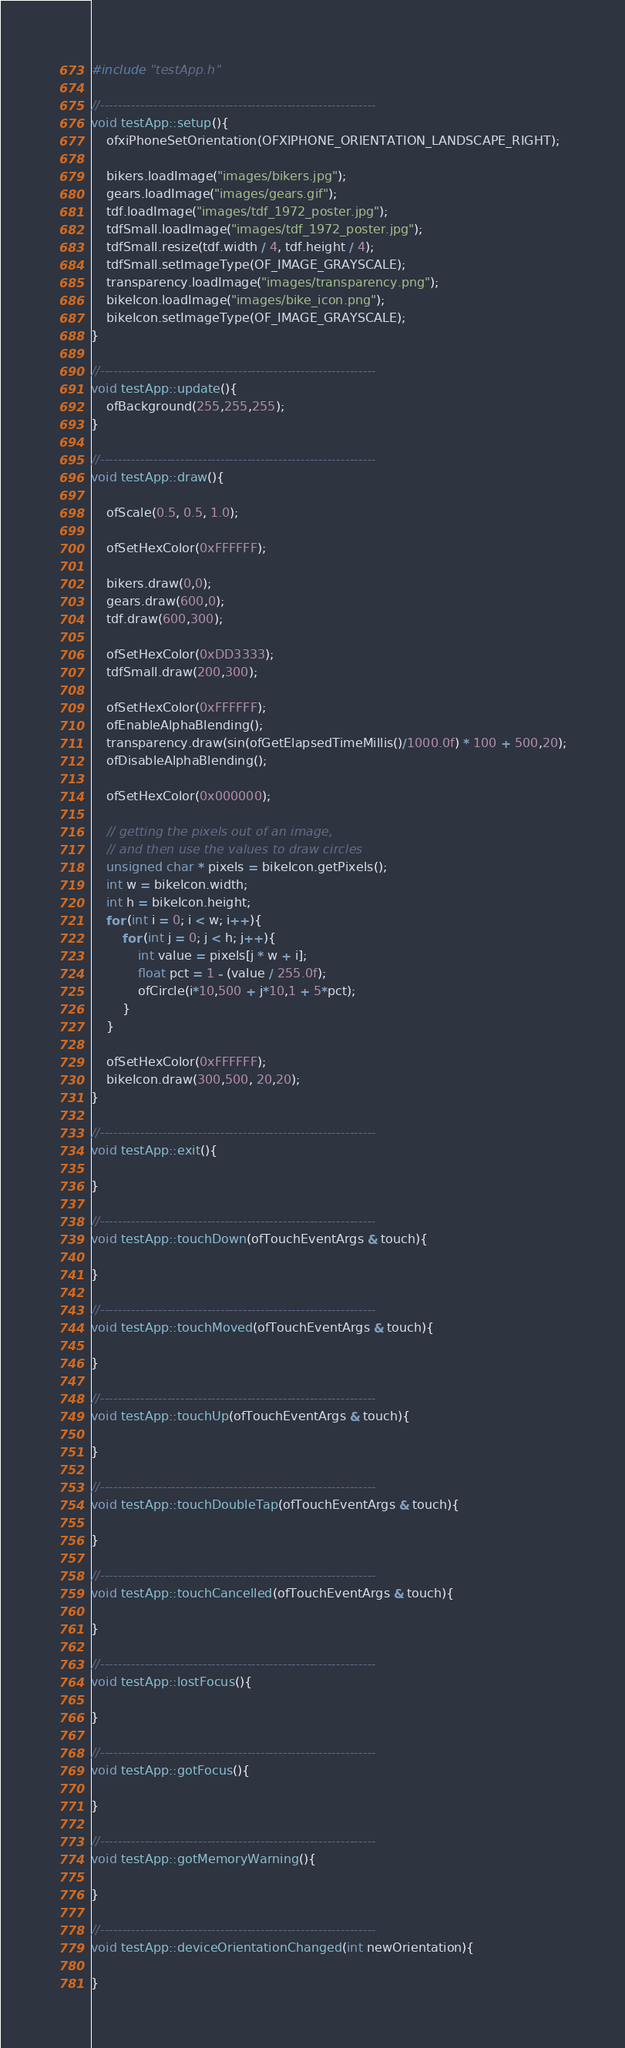Convert code to text. <code><loc_0><loc_0><loc_500><loc_500><_ObjectiveC_>#include "testApp.h"

//--------------------------------------------------------------
void testApp::setup(){	
	ofxiPhoneSetOrientation(OFXIPHONE_ORIENTATION_LANDSCAPE_RIGHT);
	
	bikers.loadImage("images/bikers.jpg");
	gears.loadImage("images/gears.gif");
	tdf.loadImage("images/tdf_1972_poster.jpg");
	tdfSmall.loadImage("images/tdf_1972_poster.jpg");
	tdfSmall.resize(tdf.width / 4, tdf.height / 4);
	tdfSmall.setImageType(OF_IMAGE_GRAYSCALE);
	transparency.loadImage("images/transparency.png");
	bikeIcon.loadImage("images/bike_icon.png");
	bikeIcon.setImageType(OF_IMAGE_GRAYSCALE);
}

//--------------------------------------------------------------
void testApp::update(){
	ofBackground(255,255,255);	
}

//--------------------------------------------------------------
void testApp::draw(){	

	ofScale(0.5, 0.5, 1.0);

	ofSetHexColor(0xFFFFFF);
	
	bikers.draw(0,0);
	gears.draw(600,0);
	tdf.draw(600,300);
	
	ofSetHexColor(0xDD3333);
	tdfSmall.draw(200,300);
	
	ofSetHexColor(0xFFFFFF);
	ofEnableAlphaBlending();
	transparency.draw(sin(ofGetElapsedTimeMillis()/1000.0f) * 100 + 500,20);
	ofDisableAlphaBlending();
	
	ofSetHexColor(0x000000);
	
	// getting the pixels out of an image, 
	// and then use the values to draw circles
	unsigned char * pixels = bikeIcon.getPixels();
	int w = bikeIcon.width;
	int h = bikeIcon.height;
	for (int i = 0; i < w; i++){
		for (int j = 0; j < h; j++){
			int value = pixels[j * w + i];
			float pct = 1 - (value / 255.0f);
			ofCircle(i*10,500 + j*10,1 + 5*pct);		
		}
	}
	
	ofSetHexColor(0xFFFFFF);
	bikeIcon.draw(300,500, 20,20);
}

//--------------------------------------------------------------
void testApp::exit(){
    
}

//--------------------------------------------------------------
void testApp::touchDown(ofTouchEventArgs & touch){

}

//--------------------------------------------------------------
void testApp::touchMoved(ofTouchEventArgs & touch){

}

//--------------------------------------------------------------
void testApp::touchUp(ofTouchEventArgs & touch){

}

//--------------------------------------------------------------
void testApp::touchDoubleTap(ofTouchEventArgs & touch){

}

//--------------------------------------------------------------
void testApp::touchCancelled(ofTouchEventArgs & touch){

}

//--------------------------------------------------------------
void testApp::lostFocus(){
    
}

//--------------------------------------------------------------
void testApp::gotFocus(){
    
}

//--------------------------------------------------------------
void testApp::gotMemoryWarning(){
    
}

//--------------------------------------------------------------
void testApp::deviceOrientationChanged(int newOrientation){
    
}


</code> 